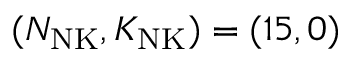Convert formula to latex. <formula><loc_0><loc_0><loc_500><loc_500>( N _ { N K } , K _ { N K } ) = ( 1 5 , 0 )</formula> 